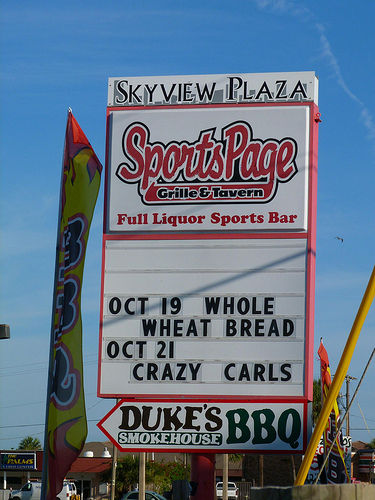<image>
Is there a flag next to the flag? No. The flag is not positioned next to the flag. They are located in different areas of the scene. 